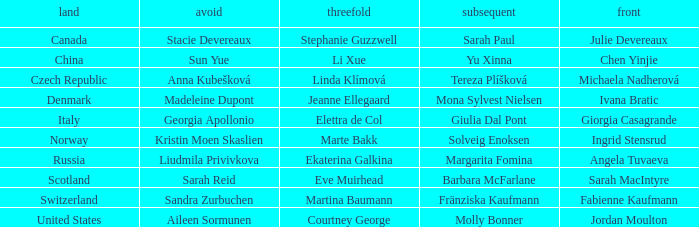What skip has norway as the country? Kristin Moen Skaslien. 